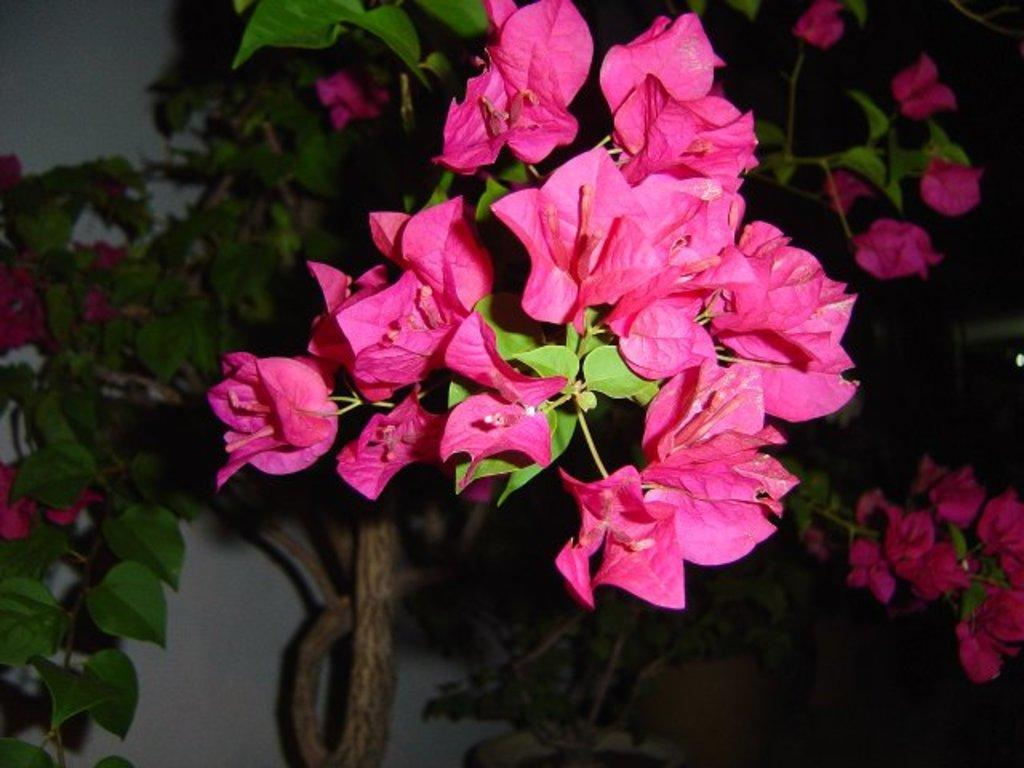What type of plant life is visible in the image? There are flowers, leaves, and stems visible in the image. What can be seen in the background of the image? The background of the image includes plants and a wall. How would you describe the lighting in the background of the image? The background view is dark. How much profit did the flowers generate in the image? There is no information about profit in the image, as it focuses on the visual representation of flowers, leaves, and stems. 